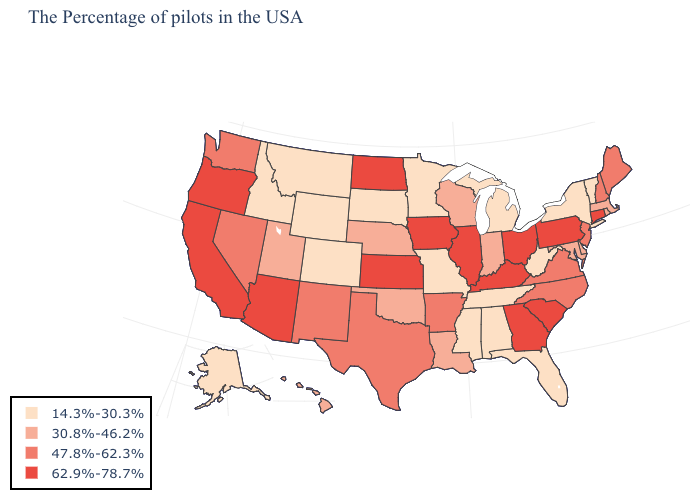What is the lowest value in states that border Texas?
Write a very short answer. 30.8%-46.2%. Among the states that border Nevada , which have the highest value?
Write a very short answer. Arizona, California, Oregon. Is the legend a continuous bar?
Be succinct. No. Name the states that have a value in the range 14.3%-30.3%?
Be succinct. Vermont, New York, West Virginia, Florida, Michigan, Alabama, Tennessee, Mississippi, Missouri, Minnesota, South Dakota, Wyoming, Colorado, Montana, Idaho, Alaska. Name the states that have a value in the range 14.3%-30.3%?
Concise answer only. Vermont, New York, West Virginia, Florida, Michigan, Alabama, Tennessee, Mississippi, Missouri, Minnesota, South Dakota, Wyoming, Colorado, Montana, Idaho, Alaska. Does West Virginia have a higher value than Kentucky?
Quick response, please. No. Which states have the highest value in the USA?
Be succinct. Connecticut, Pennsylvania, South Carolina, Ohio, Georgia, Kentucky, Illinois, Iowa, Kansas, North Dakota, Arizona, California, Oregon. What is the value of Illinois?
Answer briefly. 62.9%-78.7%. What is the value of Virginia?
Quick response, please. 47.8%-62.3%. Does Connecticut have the lowest value in the Northeast?
Give a very brief answer. No. How many symbols are there in the legend?
Write a very short answer. 4. What is the value of Oregon?
Be succinct. 62.9%-78.7%. Name the states that have a value in the range 47.8%-62.3%?
Write a very short answer. Maine, New Hampshire, New Jersey, Virginia, North Carolina, Arkansas, Texas, New Mexico, Nevada, Washington. Name the states that have a value in the range 14.3%-30.3%?
Short answer required. Vermont, New York, West Virginia, Florida, Michigan, Alabama, Tennessee, Mississippi, Missouri, Minnesota, South Dakota, Wyoming, Colorado, Montana, Idaho, Alaska. Name the states that have a value in the range 62.9%-78.7%?
Short answer required. Connecticut, Pennsylvania, South Carolina, Ohio, Georgia, Kentucky, Illinois, Iowa, Kansas, North Dakota, Arizona, California, Oregon. 